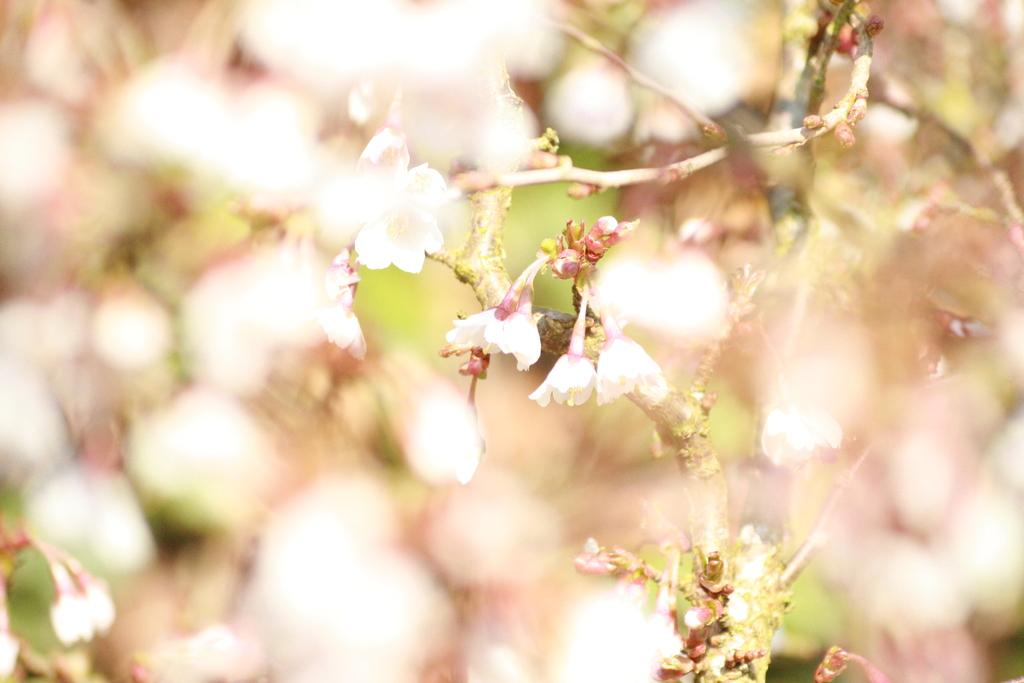What type of plant is visible in the image? There are flowers on a plant in the image. Are there any unopened flowers on the plant? Yes, there are buds on the plant in the image. Can you describe the background of the image? The background of the image is blurred. What type of yoke can be seen supporting the circle in the image? There is no yoke or circle present in the image; it features a plant with flowers and buds. 